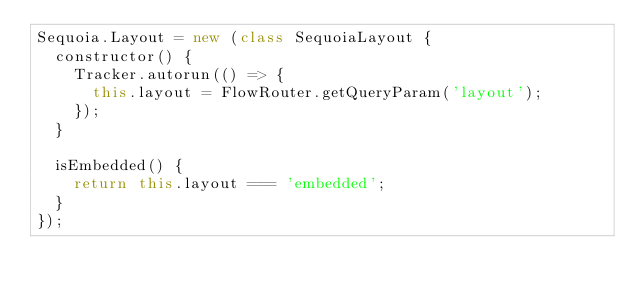Convert code to text. <code><loc_0><loc_0><loc_500><loc_500><_JavaScript_>Sequoia.Layout = new (class SequoiaLayout {
	constructor() {
		Tracker.autorun(() => {
			this.layout = FlowRouter.getQueryParam('layout');
		});
	}

	isEmbedded() {
		return this.layout === 'embedded';
	}
});
</code> 